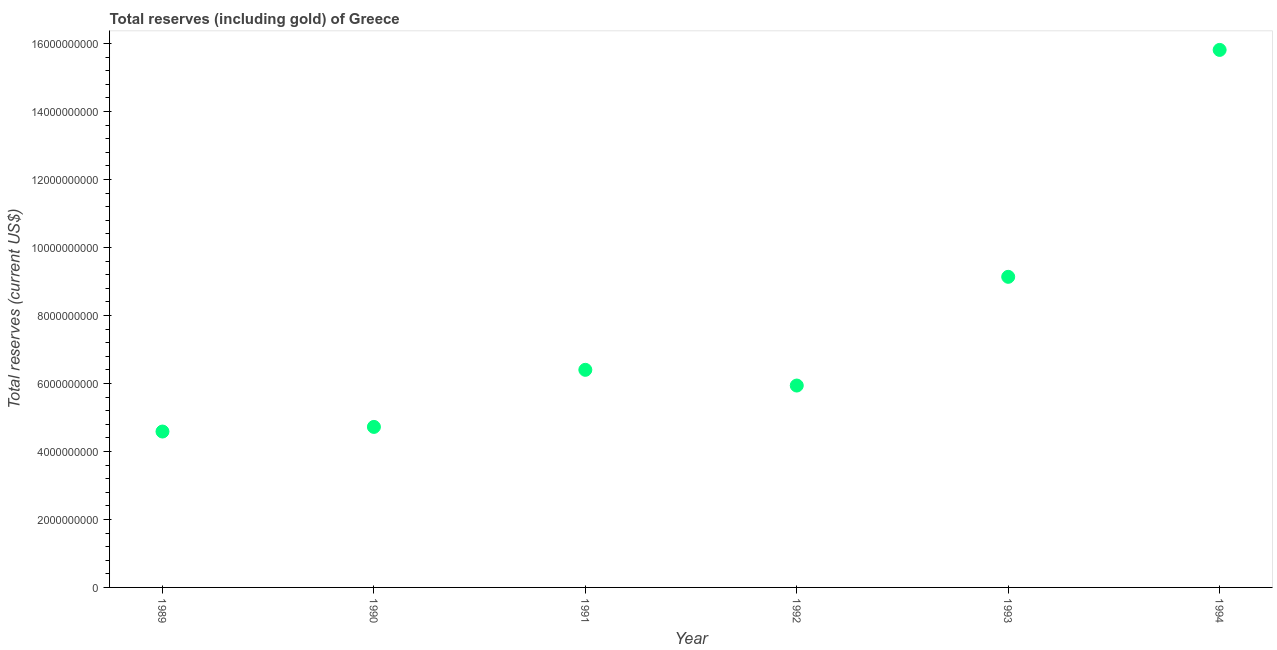What is the total reserves (including gold) in 1991?
Provide a succinct answer. 6.40e+09. Across all years, what is the maximum total reserves (including gold)?
Your answer should be compact. 1.58e+1. Across all years, what is the minimum total reserves (including gold)?
Your response must be concise. 4.58e+09. In which year was the total reserves (including gold) maximum?
Your response must be concise. 1994. In which year was the total reserves (including gold) minimum?
Give a very brief answer. 1989. What is the sum of the total reserves (including gold)?
Offer a very short reply. 4.66e+1. What is the difference between the total reserves (including gold) in 1989 and 1990?
Keep it short and to the point. -1.36e+08. What is the average total reserves (including gold) per year?
Keep it short and to the point. 7.76e+09. What is the median total reserves (including gold)?
Your answer should be very brief. 6.17e+09. Do a majority of the years between 1989 and 1994 (inclusive) have total reserves (including gold) greater than 400000000 US$?
Keep it short and to the point. Yes. What is the ratio of the total reserves (including gold) in 1990 to that in 1993?
Your answer should be compact. 0.52. Is the difference between the total reserves (including gold) in 1989 and 1991 greater than the difference between any two years?
Your answer should be compact. No. What is the difference between the highest and the second highest total reserves (including gold)?
Ensure brevity in your answer.  6.67e+09. Is the sum of the total reserves (including gold) in 1991 and 1993 greater than the maximum total reserves (including gold) across all years?
Give a very brief answer. No. What is the difference between the highest and the lowest total reserves (including gold)?
Offer a very short reply. 1.12e+1. In how many years, is the total reserves (including gold) greater than the average total reserves (including gold) taken over all years?
Offer a very short reply. 2. How many years are there in the graph?
Your answer should be very brief. 6. What is the difference between two consecutive major ticks on the Y-axis?
Offer a terse response. 2.00e+09. Does the graph contain any zero values?
Provide a succinct answer. No. What is the title of the graph?
Provide a short and direct response. Total reserves (including gold) of Greece. What is the label or title of the Y-axis?
Provide a short and direct response. Total reserves (current US$). What is the Total reserves (current US$) in 1989?
Give a very brief answer. 4.58e+09. What is the Total reserves (current US$) in 1990?
Make the answer very short. 4.72e+09. What is the Total reserves (current US$) in 1991?
Provide a succinct answer. 6.40e+09. What is the Total reserves (current US$) in 1992?
Provide a short and direct response. 5.94e+09. What is the Total reserves (current US$) in 1993?
Your answer should be very brief. 9.14e+09. What is the Total reserves (current US$) in 1994?
Offer a very short reply. 1.58e+1. What is the difference between the Total reserves (current US$) in 1989 and 1990?
Give a very brief answer. -1.36e+08. What is the difference between the Total reserves (current US$) in 1989 and 1991?
Give a very brief answer. -1.82e+09. What is the difference between the Total reserves (current US$) in 1989 and 1992?
Provide a succinct answer. -1.35e+09. What is the difference between the Total reserves (current US$) in 1989 and 1993?
Your answer should be very brief. -4.55e+09. What is the difference between the Total reserves (current US$) in 1989 and 1994?
Keep it short and to the point. -1.12e+1. What is the difference between the Total reserves (current US$) in 1990 and 1991?
Your answer should be very brief. -1.68e+09. What is the difference between the Total reserves (current US$) in 1990 and 1992?
Offer a very short reply. -1.22e+09. What is the difference between the Total reserves (current US$) in 1990 and 1993?
Offer a very short reply. -4.41e+09. What is the difference between the Total reserves (current US$) in 1990 and 1994?
Ensure brevity in your answer.  -1.11e+1. What is the difference between the Total reserves (current US$) in 1991 and 1992?
Make the answer very short. 4.62e+08. What is the difference between the Total reserves (current US$) in 1991 and 1993?
Your answer should be very brief. -2.74e+09. What is the difference between the Total reserves (current US$) in 1991 and 1994?
Provide a succinct answer. -9.41e+09. What is the difference between the Total reserves (current US$) in 1992 and 1993?
Your answer should be compact. -3.20e+09. What is the difference between the Total reserves (current US$) in 1992 and 1994?
Make the answer very short. -9.87e+09. What is the difference between the Total reserves (current US$) in 1993 and 1994?
Your answer should be compact. -6.67e+09. What is the ratio of the Total reserves (current US$) in 1989 to that in 1990?
Offer a terse response. 0.97. What is the ratio of the Total reserves (current US$) in 1989 to that in 1991?
Give a very brief answer. 0.72. What is the ratio of the Total reserves (current US$) in 1989 to that in 1992?
Your answer should be very brief. 0.77. What is the ratio of the Total reserves (current US$) in 1989 to that in 1993?
Your answer should be compact. 0.5. What is the ratio of the Total reserves (current US$) in 1989 to that in 1994?
Ensure brevity in your answer.  0.29. What is the ratio of the Total reserves (current US$) in 1990 to that in 1991?
Your answer should be compact. 0.74. What is the ratio of the Total reserves (current US$) in 1990 to that in 1992?
Make the answer very short. 0.8. What is the ratio of the Total reserves (current US$) in 1990 to that in 1993?
Offer a terse response. 0.52. What is the ratio of the Total reserves (current US$) in 1990 to that in 1994?
Keep it short and to the point. 0.3. What is the ratio of the Total reserves (current US$) in 1991 to that in 1992?
Provide a succinct answer. 1.08. What is the ratio of the Total reserves (current US$) in 1991 to that in 1993?
Ensure brevity in your answer.  0.7. What is the ratio of the Total reserves (current US$) in 1991 to that in 1994?
Offer a very short reply. 0.41. What is the ratio of the Total reserves (current US$) in 1992 to that in 1993?
Offer a terse response. 0.65. What is the ratio of the Total reserves (current US$) in 1992 to that in 1994?
Your response must be concise. 0.38. What is the ratio of the Total reserves (current US$) in 1993 to that in 1994?
Provide a succinct answer. 0.58. 